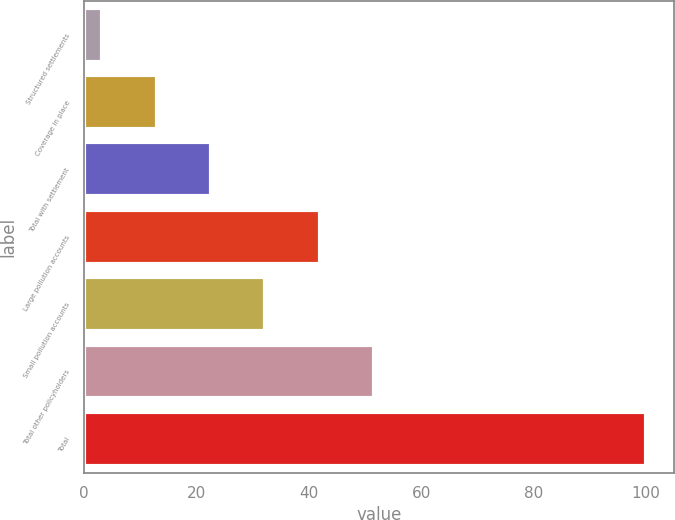Convert chart. <chart><loc_0><loc_0><loc_500><loc_500><bar_chart><fcel>Structured settlements<fcel>Coverage in place<fcel>Total with settlement<fcel>Large pollution accounts<fcel>Small pollution accounts<fcel>Total other policyholders<fcel>Total<nl><fcel>3.2<fcel>12.88<fcel>22.56<fcel>41.92<fcel>32.24<fcel>51.6<fcel>100<nl></chart> 